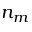Convert formula to latex. <formula><loc_0><loc_0><loc_500><loc_500>n _ { m }</formula> 